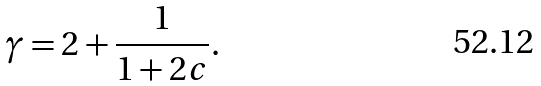<formula> <loc_0><loc_0><loc_500><loc_500>\gamma = 2 + \frac { 1 } { 1 + 2 c } .</formula> 